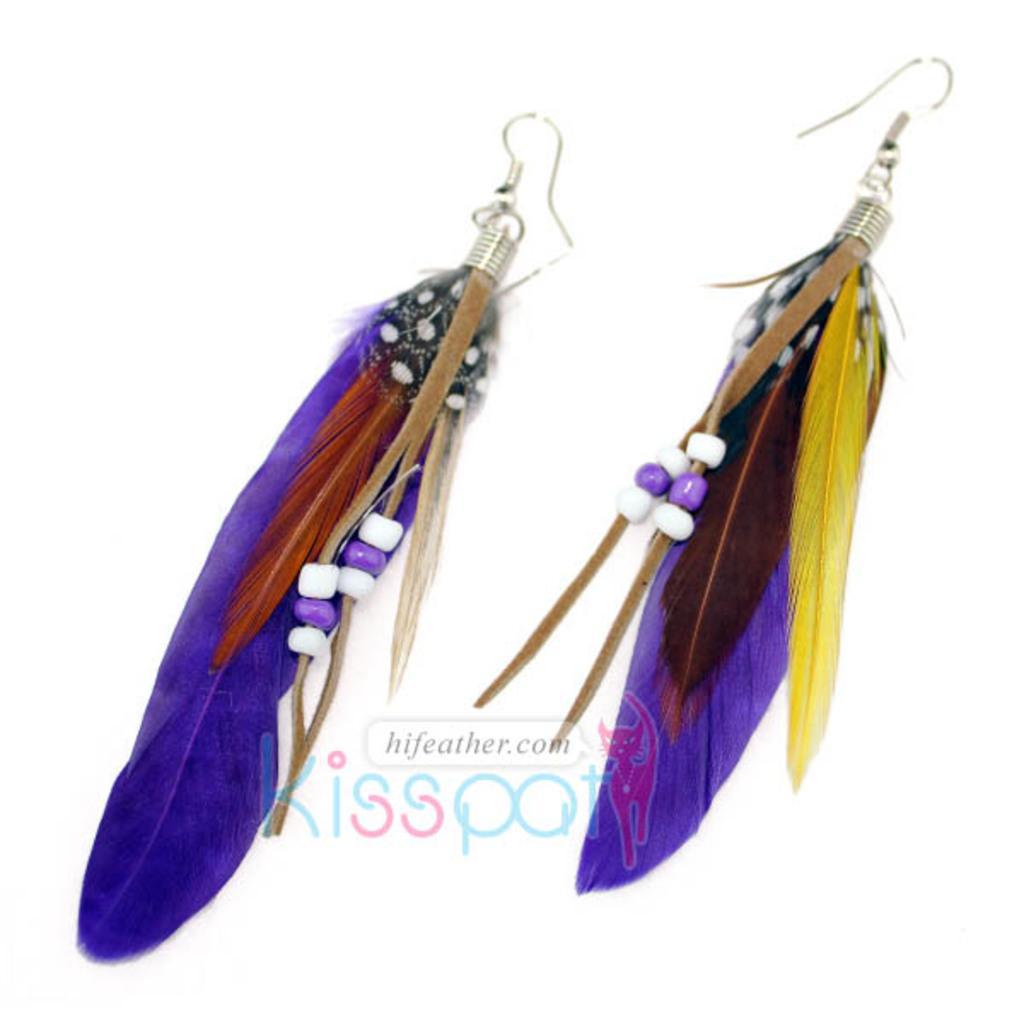Can you describe this image briefly? In this image I can see two earrings. It seems to be an edited image. At the bottom there is some text. The background is in white color. 